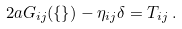Convert formula to latex. <formula><loc_0><loc_0><loc_500><loc_500>2 a G _ { i j } ( \{ \} ) - \eta _ { i j } \delta = T _ { i j } \, .</formula> 